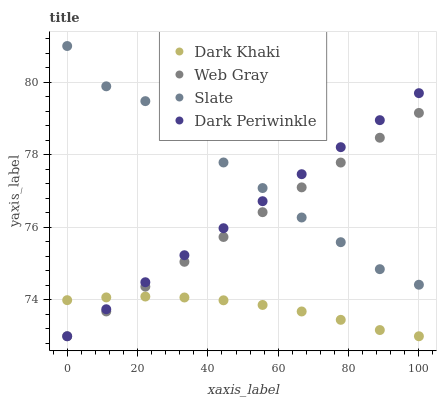Does Dark Khaki have the minimum area under the curve?
Answer yes or no. Yes. Does Slate have the maximum area under the curve?
Answer yes or no. Yes. Does Web Gray have the minimum area under the curve?
Answer yes or no. No. Does Web Gray have the maximum area under the curve?
Answer yes or no. No. Is Dark Periwinkle the smoothest?
Answer yes or no. Yes. Is Slate the roughest?
Answer yes or no. Yes. Is Web Gray the smoothest?
Answer yes or no. No. Is Web Gray the roughest?
Answer yes or no. No. Does Dark Khaki have the lowest value?
Answer yes or no. Yes. Does Slate have the lowest value?
Answer yes or no. No. Does Slate have the highest value?
Answer yes or no. Yes. Does Web Gray have the highest value?
Answer yes or no. No. Is Dark Khaki less than Slate?
Answer yes or no. Yes. Is Slate greater than Dark Khaki?
Answer yes or no. Yes. Does Dark Khaki intersect Dark Periwinkle?
Answer yes or no. Yes. Is Dark Khaki less than Dark Periwinkle?
Answer yes or no. No. Is Dark Khaki greater than Dark Periwinkle?
Answer yes or no. No. Does Dark Khaki intersect Slate?
Answer yes or no. No. 